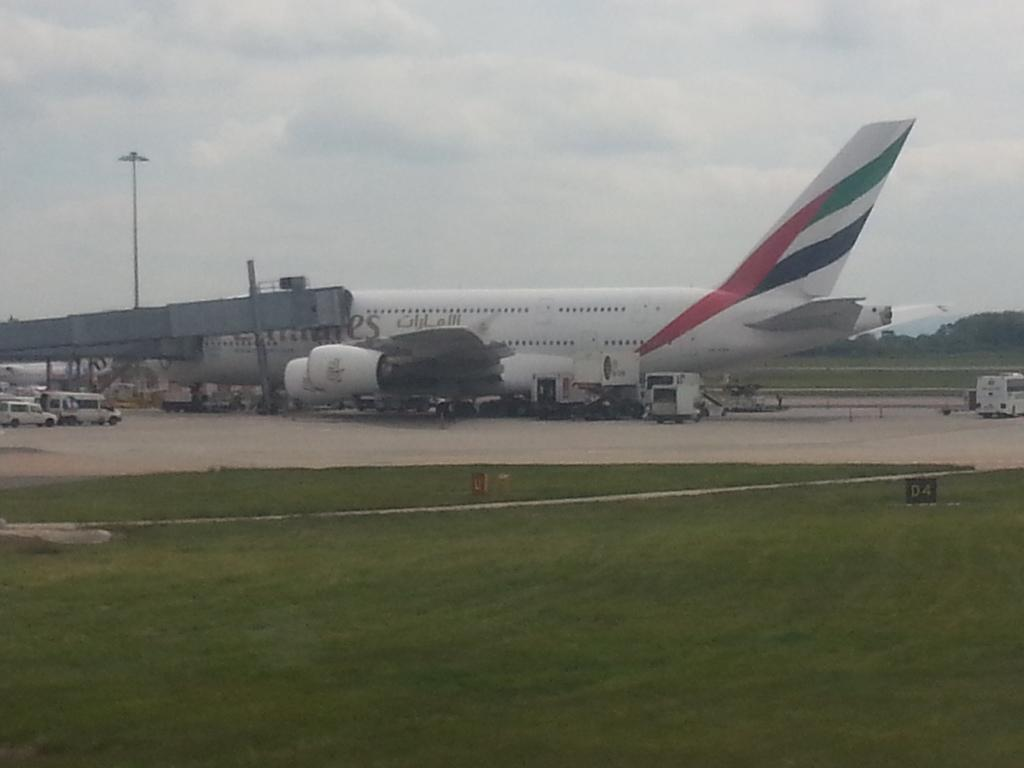What type of vegetation is present in the image? There is grass in the image. What mode of transportation can be seen in the image? There is an airplane in the image. What type of structure is present in the image? There is a tunnel in the image. What type of vehicles are on the road in the image? There are vehicles on the road in the image. What type of vertical structure is present in the image? There is a light pole in the image. What type of natural feature is present in the image? There are trees in the image. What is the condition of the sky in the background of the image? The sky in the background of the image is cloudy. What type of liquid is being poured from the light pole in the image? There is no liquid being poured from the light pole in the image. What type of milk is being served in the room in the image? There is no room or milk present in the image. 